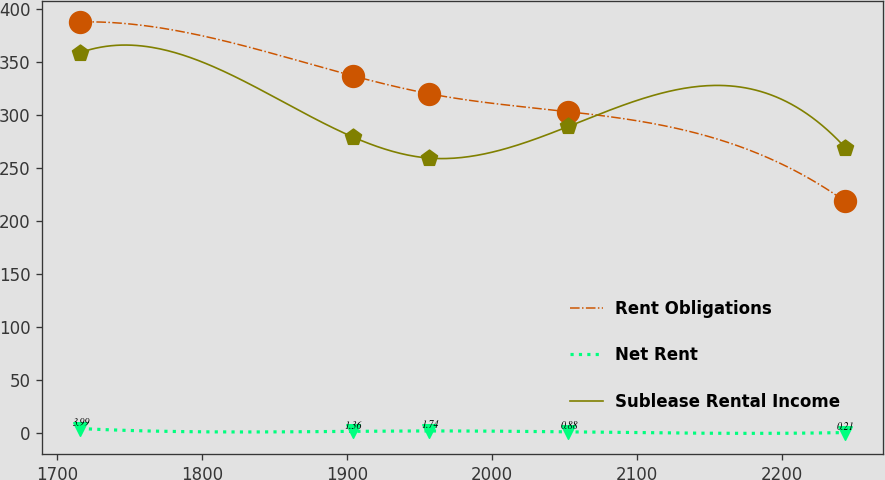<chart> <loc_0><loc_0><loc_500><loc_500><line_chart><ecel><fcel>Rent Obligations<fcel>Net Rent<fcel>Sublease Rental Income<nl><fcel>1715.9<fcel>387.94<fcel>3.99<fcel>359.06<nl><fcel>1903.95<fcel>337.05<fcel>1.36<fcel>279.29<nl><fcel>1956.74<fcel>320.11<fcel>1.74<fcel>259.35<nl><fcel>2052.77<fcel>303.17<fcel>0.88<fcel>289.26<nl><fcel>2243.81<fcel>218.53<fcel>0.21<fcel>269.32<nl></chart> 